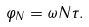Convert formula to latex. <formula><loc_0><loc_0><loc_500><loc_500>\varphi _ { N } = \omega { N } \tau .</formula> 